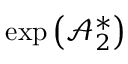<formula> <loc_0><loc_0><loc_500><loc_500>\exp \left ( \mathcal { A } _ { 2 } ^ { \ast } \right )</formula> 